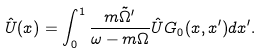<formula> <loc_0><loc_0><loc_500><loc_500>\hat { U } ( x ) = \int _ { 0 } ^ { 1 } \frac { m \tilde { \Omega } ^ { \prime } } { \omega - m \Omega } \hat { U } G _ { 0 } ( x , x ^ { \prime } ) d x ^ { \prime } .</formula> 